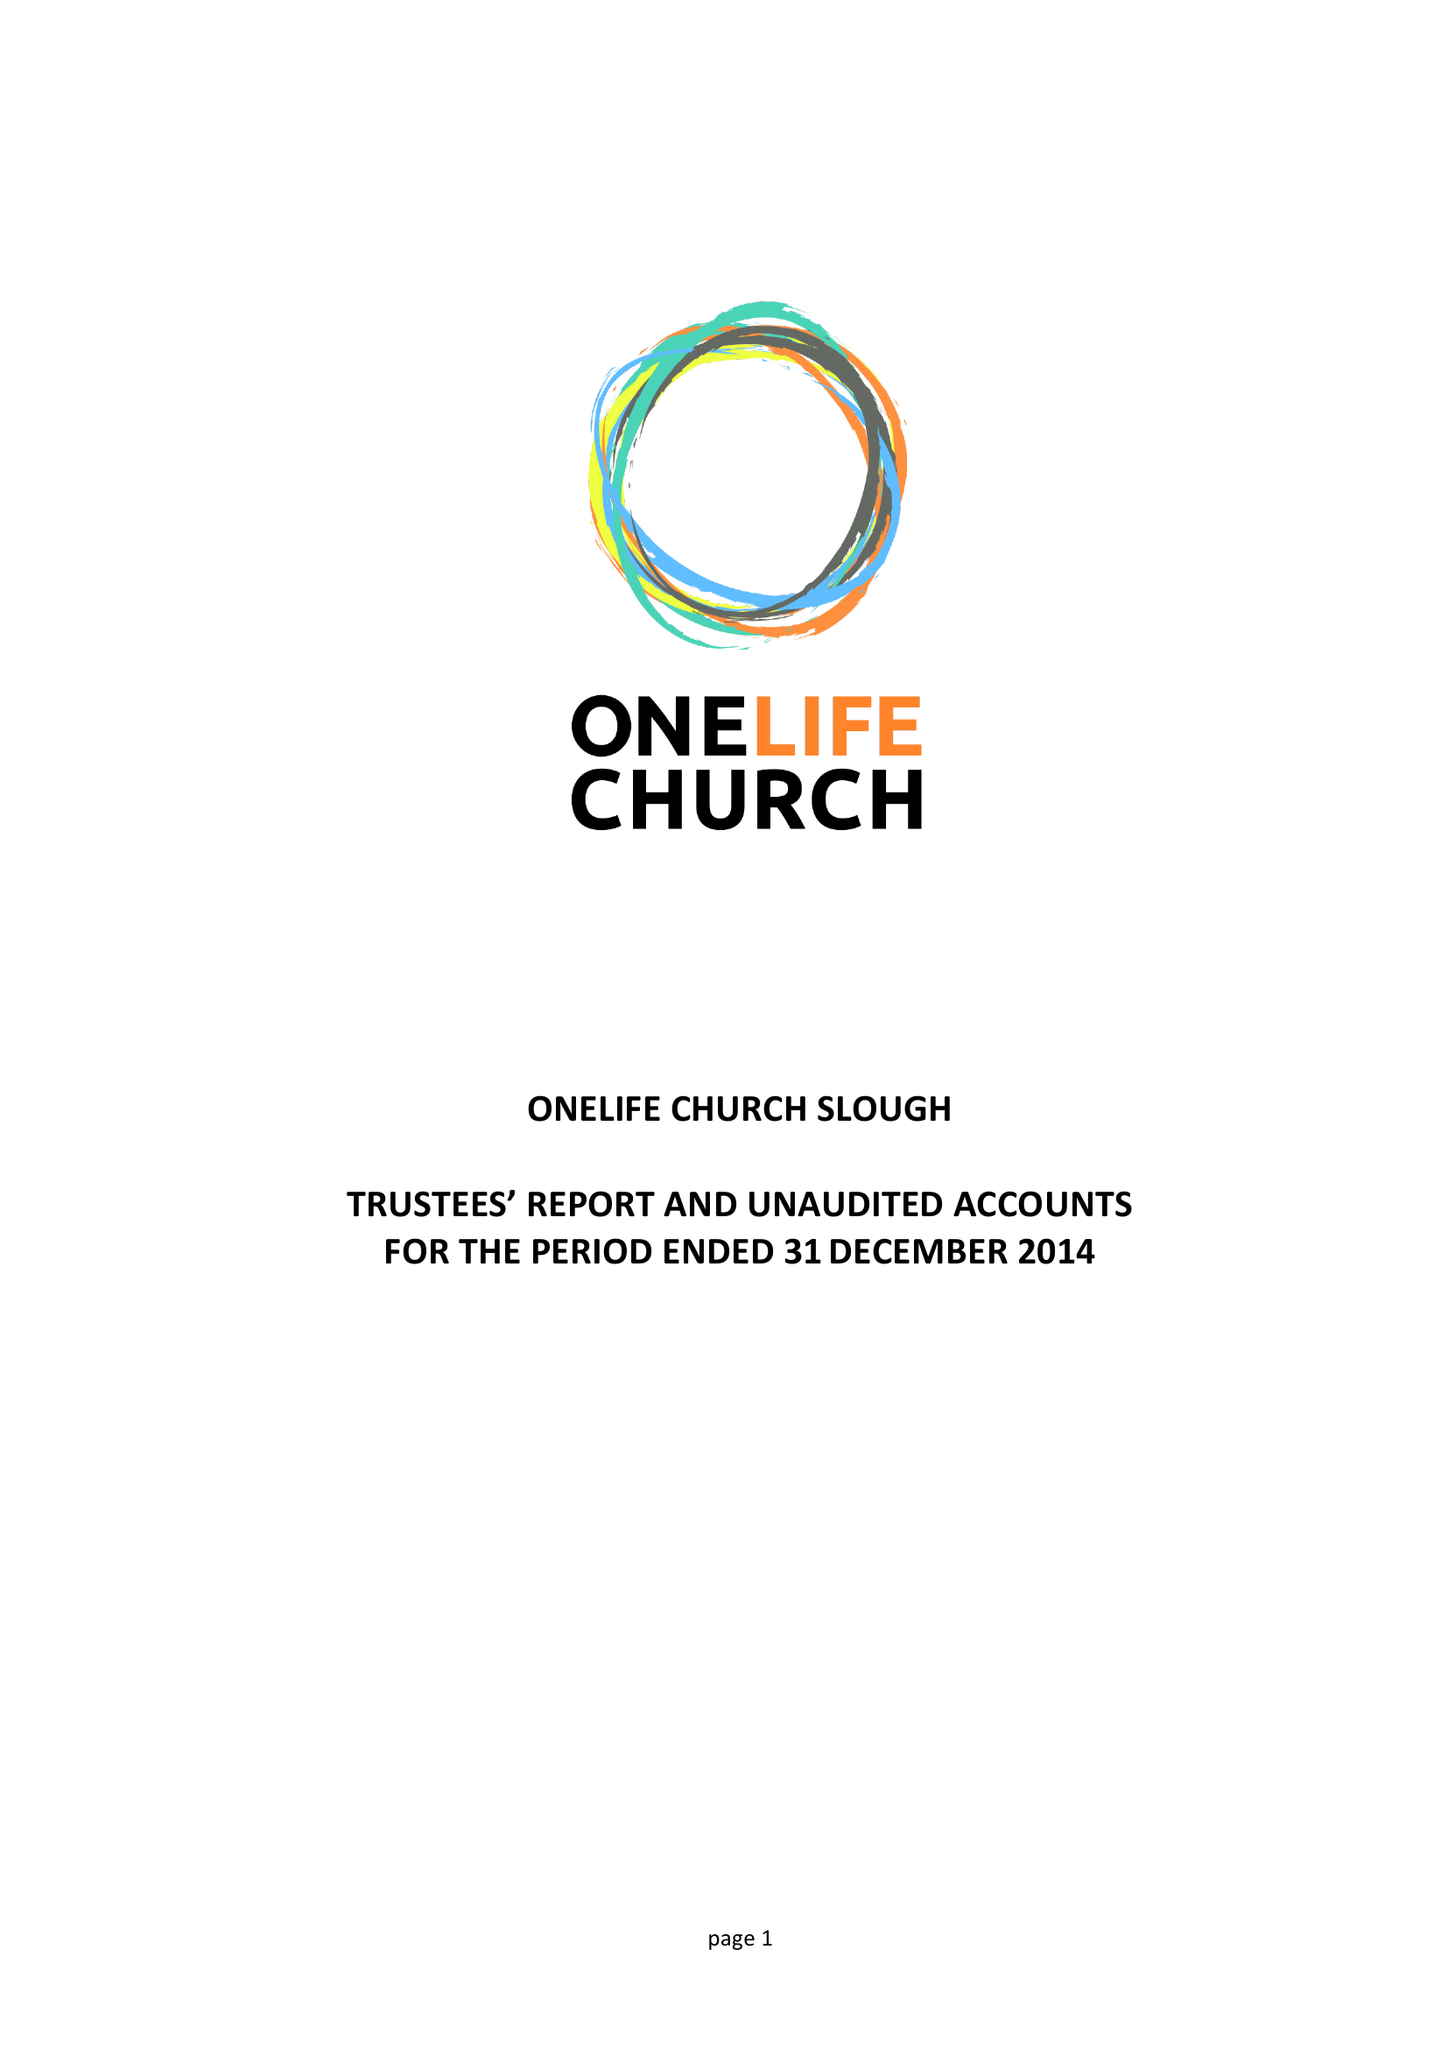What is the value for the income_annually_in_british_pounds?
Answer the question using a single word or phrase. 37088.00 